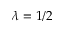<formula> <loc_0><loc_0><loc_500><loc_500>\lambda = 1 / 2</formula> 